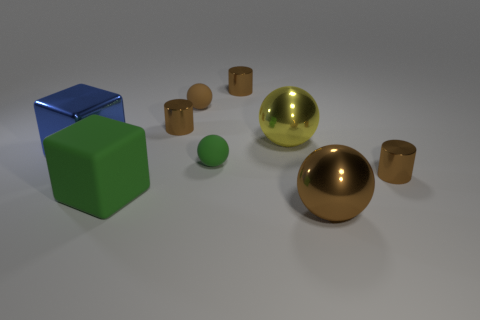Subtract 1 balls. How many balls are left? 3 Add 1 large purple shiny cylinders. How many objects exist? 10 Subtract all cubes. How many objects are left? 7 Subtract 2 brown cylinders. How many objects are left? 7 Subtract all small brown things. Subtract all rubber cubes. How many objects are left? 4 Add 2 tiny green rubber spheres. How many tiny green rubber spheres are left? 3 Add 4 large purple metal blocks. How many large purple metal blocks exist? 4 